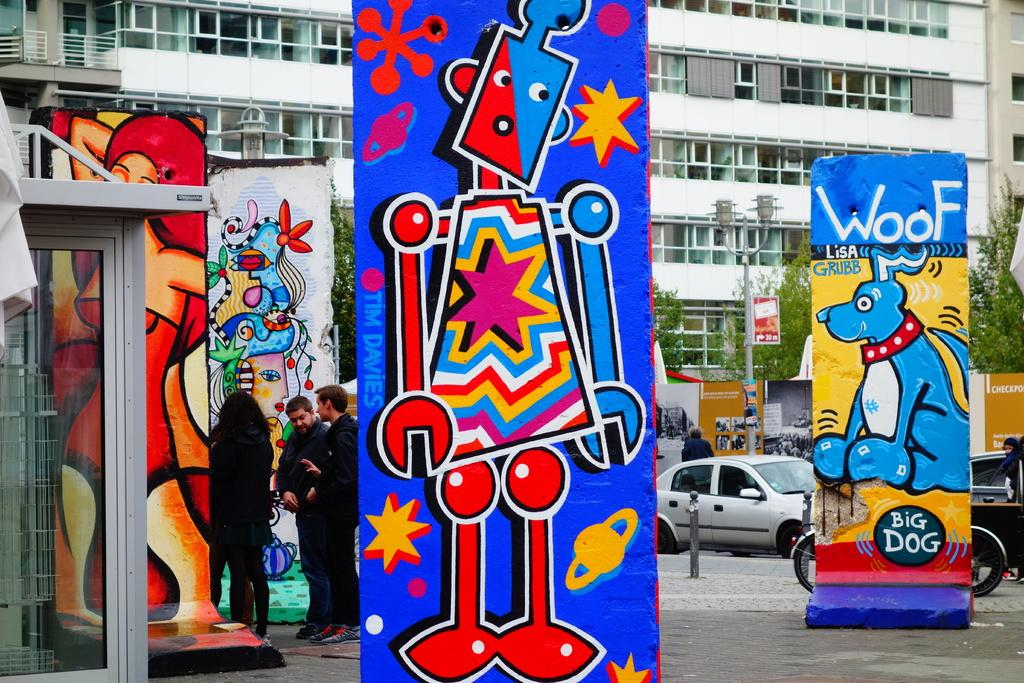<image>
Summarize the visual content of the image. A painting of a blue dog with the word WOOF above it on the street. 